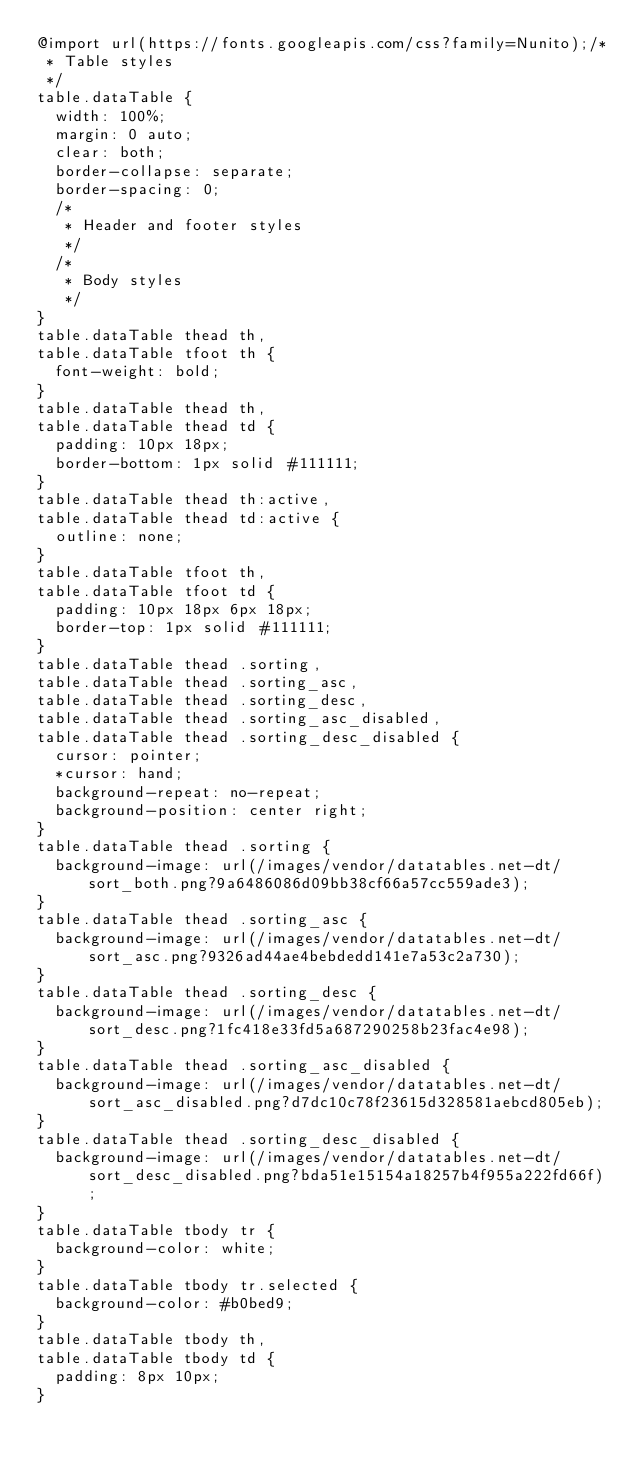Convert code to text. <code><loc_0><loc_0><loc_500><loc_500><_CSS_>@import url(https://fonts.googleapis.com/css?family=Nunito);/*
 * Table styles
 */
table.dataTable {
  width: 100%;
  margin: 0 auto;
  clear: both;
  border-collapse: separate;
  border-spacing: 0;
  /*
   * Header and footer styles
   */
  /*
   * Body styles
   */
}
table.dataTable thead th,
table.dataTable tfoot th {
  font-weight: bold;
}
table.dataTable thead th,
table.dataTable thead td {
  padding: 10px 18px;
  border-bottom: 1px solid #111111;
}
table.dataTable thead th:active,
table.dataTable thead td:active {
  outline: none;
}
table.dataTable tfoot th,
table.dataTable tfoot td {
  padding: 10px 18px 6px 18px;
  border-top: 1px solid #111111;
}
table.dataTable thead .sorting,
table.dataTable thead .sorting_asc,
table.dataTable thead .sorting_desc,
table.dataTable thead .sorting_asc_disabled,
table.dataTable thead .sorting_desc_disabled {
  cursor: pointer;
  *cursor: hand;
  background-repeat: no-repeat;
  background-position: center right;
}
table.dataTable thead .sorting {
  background-image: url(/images/vendor/datatables.net-dt/sort_both.png?9a6486086d09bb38cf66a57cc559ade3);
}
table.dataTable thead .sorting_asc {
  background-image: url(/images/vendor/datatables.net-dt/sort_asc.png?9326ad44ae4bebdedd141e7a53c2a730);
}
table.dataTable thead .sorting_desc {
  background-image: url(/images/vendor/datatables.net-dt/sort_desc.png?1fc418e33fd5a687290258b23fac4e98);
}
table.dataTable thead .sorting_asc_disabled {
  background-image: url(/images/vendor/datatables.net-dt/sort_asc_disabled.png?d7dc10c78f23615d328581aebcd805eb);
}
table.dataTable thead .sorting_desc_disabled {
  background-image: url(/images/vendor/datatables.net-dt/sort_desc_disabled.png?bda51e15154a18257b4f955a222fd66f);
}
table.dataTable tbody tr {
  background-color: white;
}
table.dataTable tbody tr.selected {
  background-color: #b0bed9;
}
table.dataTable tbody th,
table.dataTable tbody td {
  padding: 8px 10px;
}</code> 